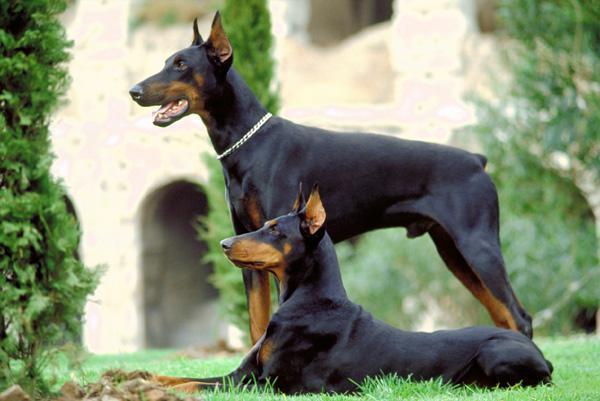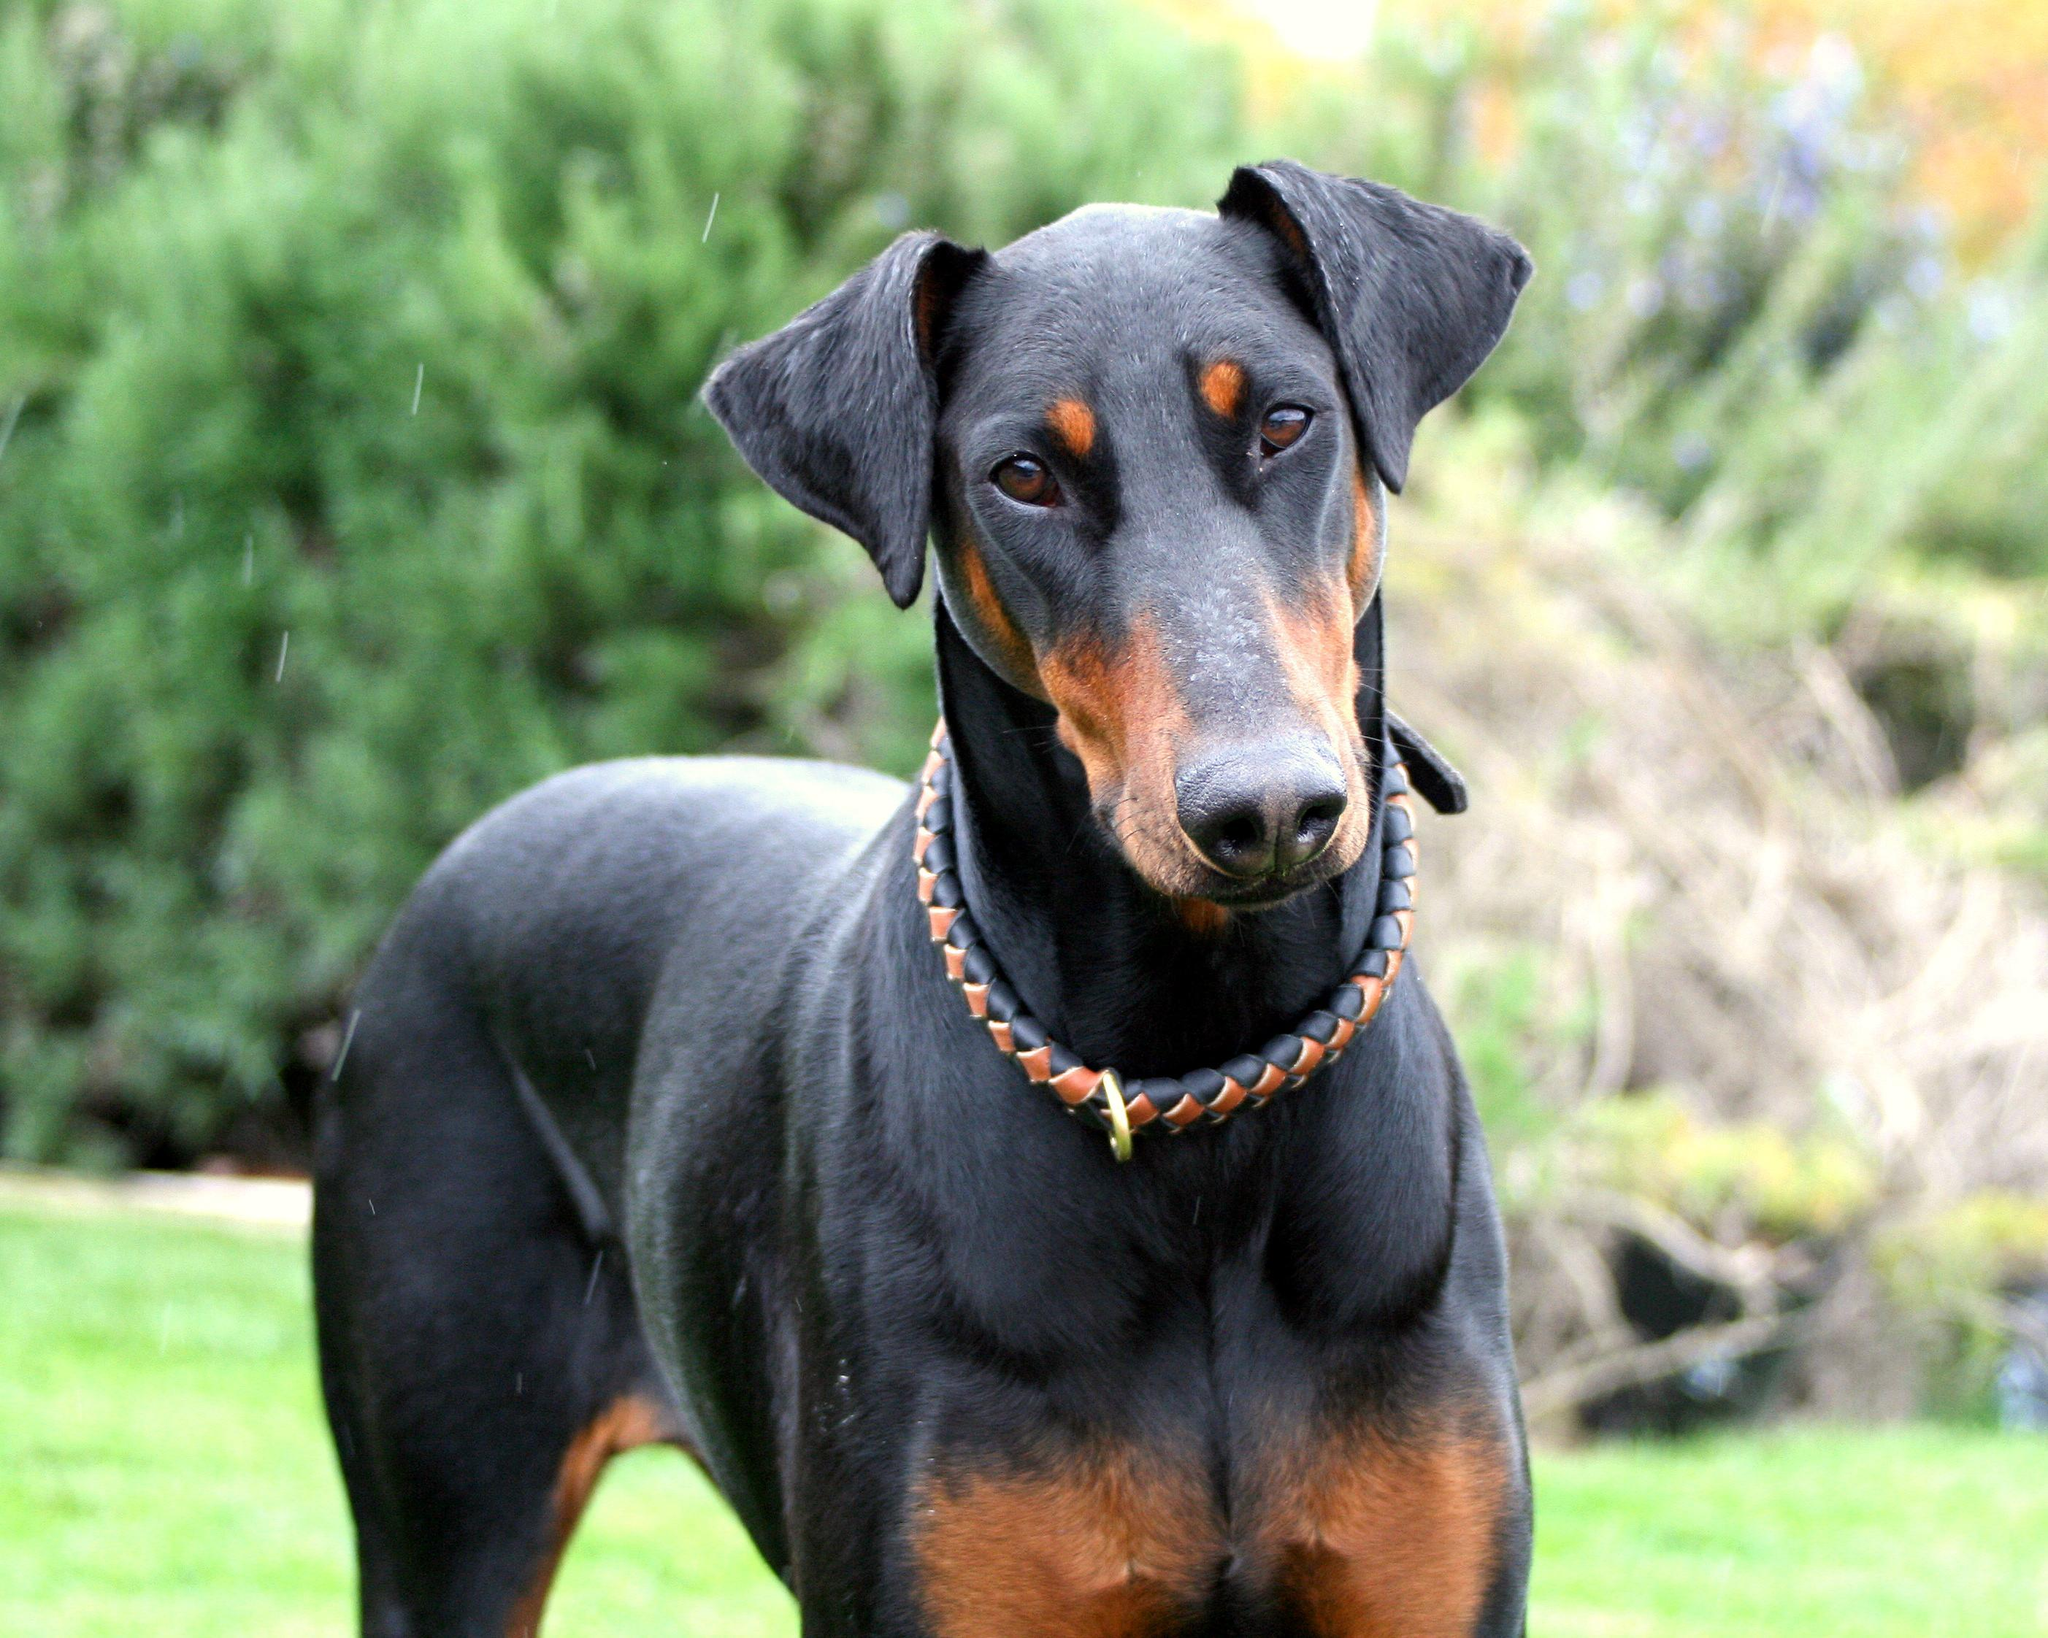The first image is the image on the left, the second image is the image on the right. Considering the images on both sides, is "The right image contains at least two dogs." valid? Answer yes or no. No. 